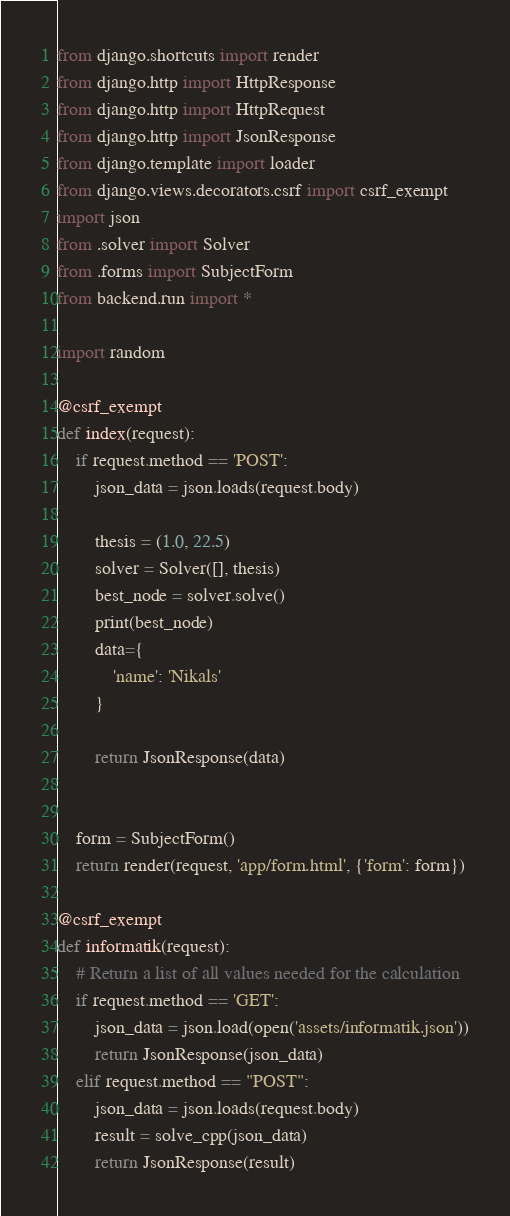Convert code to text. <code><loc_0><loc_0><loc_500><loc_500><_Python_>from django.shortcuts import render
from django.http import HttpResponse
from django.http import HttpRequest
from django.http import JsonResponse
from django.template import loader
from django.views.decorators.csrf import csrf_exempt
import json
from .solver import Solver
from .forms import SubjectForm
from backend.run import *

import random

@csrf_exempt
def index(request):
    if request.method == 'POST':
        json_data = json.loads(request.body)
        
        thesis = (1.0, 22.5)
        solver = Solver([], thesis)
        best_node = solver.solve()
        print(best_node)
        data={
            'name': 'Nikals'
        }

        return JsonResponse(data)


    form = SubjectForm()
    return render(request, 'app/form.html', {'form': form})

@csrf_exempt
def informatik(request):
    # Return a list of all values needed for the calculation
    if request.method == 'GET':
        json_data = json.load(open('assets/informatik.json'))
        return JsonResponse(json_data)
    elif request.method == "POST":
        json_data = json.loads(request.body)
        result = solve_cpp(json_data)
        return JsonResponse(result)</code> 